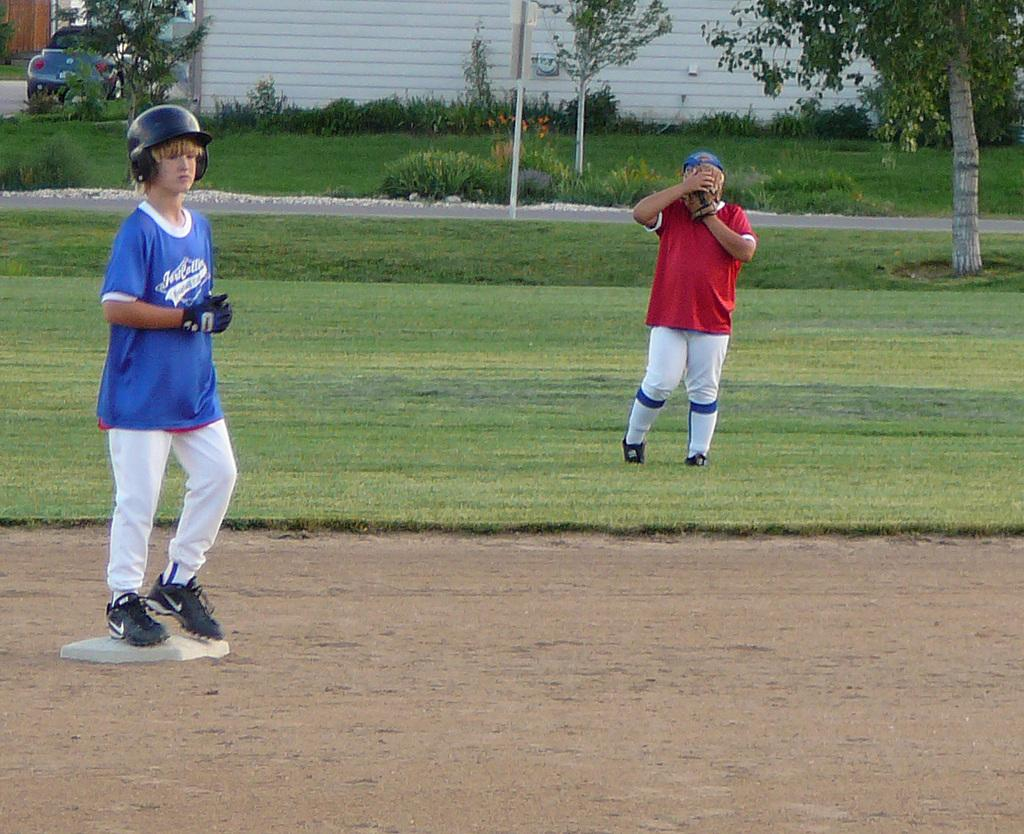What are the two people wearing in the image? One person is wearing gloves and a helmet, and another person is also wearing gloves and a helmet. What is the terrain like in the image? The land is covered with grass. What can be seen in the background of the image? There are trees, plants, and a vehicle in the background. What type of meat is being cooked on the grill in the image? There is no grill or meat present in the image. Where can the person be seen sleeping in the image? There is no person sleeping in the image. 